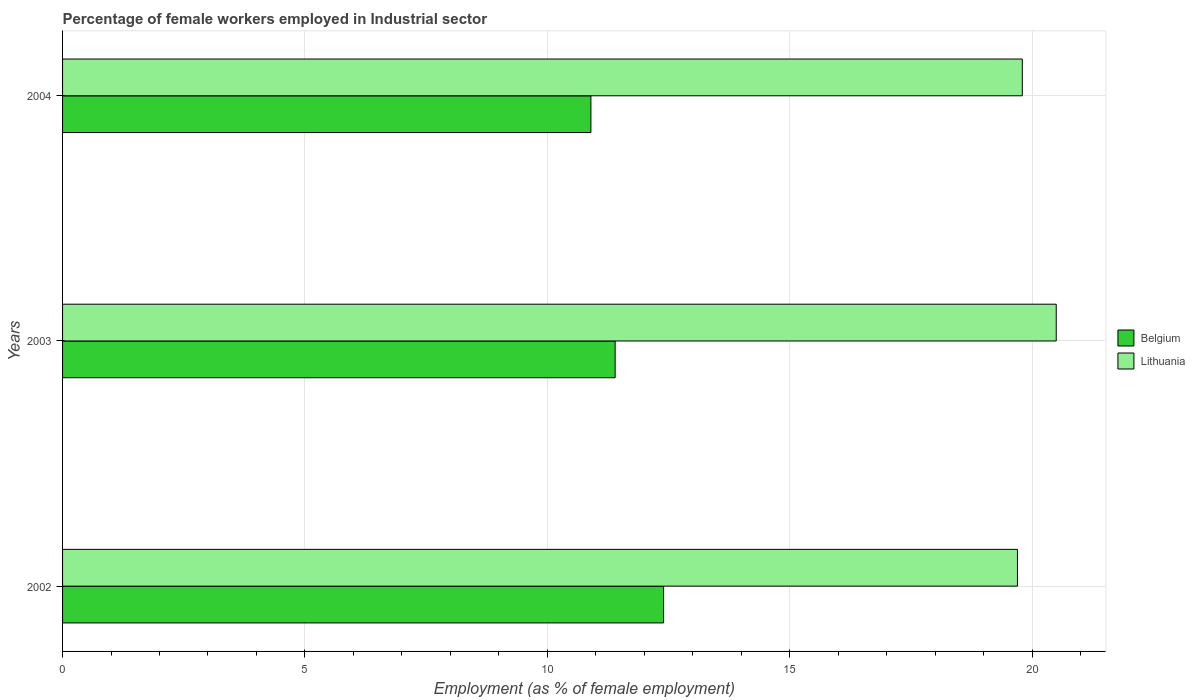How many bars are there on the 2nd tick from the top?
Make the answer very short. 2. How many bars are there on the 1st tick from the bottom?
Your response must be concise. 2. In how many cases, is the number of bars for a given year not equal to the number of legend labels?
Give a very brief answer. 0. What is the percentage of females employed in Industrial sector in Belgium in 2004?
Your answer should be very brief. 10.9. Across all years, what is the maximum percentage of females employed in Industrial sector in Belgium?
Provide a short and direct response. 12.4. Across all years, what is the minimum percentage of females employed in Industrial sector in Belgium?
Give a very brief answer. 10.9. What is the total percentage of females employed in Industrial sector in Lithuania in the graph?
Ensure brevity in your answer.  60. What is the difference between the percentage of females employed in Industrial sector in Lithuania in 2002 and that in 2004?
Provide a succinct answer. -0.1. What is the difference between the percentage of females employed in Industrial sector in Lithuania in 2004 and the percentage of females employed in Industrial sector in Belgium in 2002?
Ensure brevity in your answer.  7.4. What is the average percentage of females employed in Industrial sector in Lithuania per year?
Your response must be concise. 20. In the year 2002, what is the difference between the percentage of females employed in Industrial sector in Lithuania and percentage of females employed in Industrial sector in Belgium?
Your answer should be very brief. 7.3. In how many years, is the percentage of females employed in Industrial sector in Belgium greater than 1 %?
Make the answer very short. 3. What is the ratio of the percentage of females employed in Industrial sector in Belgium in 2002 to that in 2004?
Ensure brevity in your answer.  1.14. Is the percentage of females employed in Industrial sector in Belgium in 2002 less than that in 2004?
Ensure brevity in your answer.  No. Is the difference between the percentage of females employed in Industrial sector in Lithuania in 2002 and 2003 greater than the difference between the percentage of females employed in Industrial sector in Belgium in 2002 and 2003?
Make the answer very short. No. What is the difference between the highest and the second highest percentage of females employed in Industrial sector in Lithuania?
Make the answer very short. 0.7. In how many years, is the percentage of females employed in Industrial sector in Lithuania greater than the average percentage of females employed in Industrial sector in Lithuania taken over all years?
Provide a succinct answer. 1. What does the 2nd bar from the bottom in 2003 represents?
Make the answer very short. Lithuania. How many bars are there?
Provide a short and direct response. 6. What is the difference between two consecutive major ticks on the X-axis?
Ensure brevity in your answer.  5. Does the graph contain any zero values?
Your answer should be compact. No. How are the legend labels stacked?
Give a very brief answer. Vertical. What is the title of the graph?
Your answer should be compact. Percentage of female workers employed in Industrial sector. What is the label or title of the X-axis?
Offer a terse response. Employment (as % of female employment). What is the Employment (as % of female employment) of Belgium in 2002?
Your answer should be very brief. 12.4. What is the Employment (as % of female employment) of Lithuania in 2002?
Provide a short and direct response. 19.7. What is the Employment (as % of female employment) of Belgium in 2003?
Your response must be concise. 11.4. What is the Employment (as % of female employment) in Lithuania in 2003?
Your response must be concise. 20.5. What is the Employment (as % of female employment) in Belgium in 2004?
Provide a succinct answer. 10.9. What is the Employment (as % of female employment) in Lithuania in 2004?
Give a very brief answer. 19.8. Across all years, what is the maximum Employment (as % of female employment) in Belgium?
Your answer should be very brief. 12.4. Across all years, what is the maximum Employment (as % of female employment) of Lithuania?
Offer a terse response. 20.5. Across all years, what is the minimum Employment (as % of female employment) of Belgium?
Offer a very short reply. 10.9. Across all years, what is the minimum Employment (as % of female employment) in Lithuania?
Provide a succinct answer. 19.7. What is the total Employment (as % of female employment) of Belgium in the graph?
Offer a terse response. 34.7. What is the total Employment (as % of female employment) in Lithuania in the graph?
Make the answer very short. 60. What is the difference between the Employment (as % of female employment) of Belgium in 2003 and that in 2004?
Your response must be concise. 0.5. What is the difference between the Employment (as % of female employment) in Lithuania in 2003 and that in 2004?
Provide a short and direct response. 0.7. What is the difference between the Employment (as % of female employment) in Belgium in 2002 and the Employment (as % of female employment) in Lithuania in 2003?
Make the answer very short. -8.1. What is the average Employment (as % of female employment) of Belgium per year?
Give a very brief answer. 11.57. What is the average Employment (as % of female employment) in Lithuania per year?
Keep it short and to the point. 20. In the year 2002, what is the difference between the Employment (as % of female employment) in Belgium and Employment (as % of female employment) in Lithuania?
Make the answer very short. -7.3. In the year 2004, what is the difference between the Employment (as % of female employment) of Belgium and Employment (as % of female employment) of Lithuania?
Offer a very short reply. -8.9. What is the ratio of the Employment (as % of female employment) in Belgium in 2002 to that in 2003?
Your answer should be compact. 1.09. What is the ratio of the Employment (as % of female employment) in Belgium in 2002 to that in 2004?
Your answer should be very brief. 1.14. What is the ratio of the Employment (as % of female employment) of Belgium in 2003 to that in 2004?
Your answer should be compact. 1.05. What is the ratio of the Employment (as % of female employment) of Lithuania in 2003 to that in 2004?
Give a very brief answer. 1.04. What is the difference between the highest and the lowest Employment (as % of female employment) in Belgium?
Provide a succinct answer. 1.5. What is the difference between the highest and the lowest Employment (as % of female employment) of Lithuania?
Make the answer very short. 0.8. 